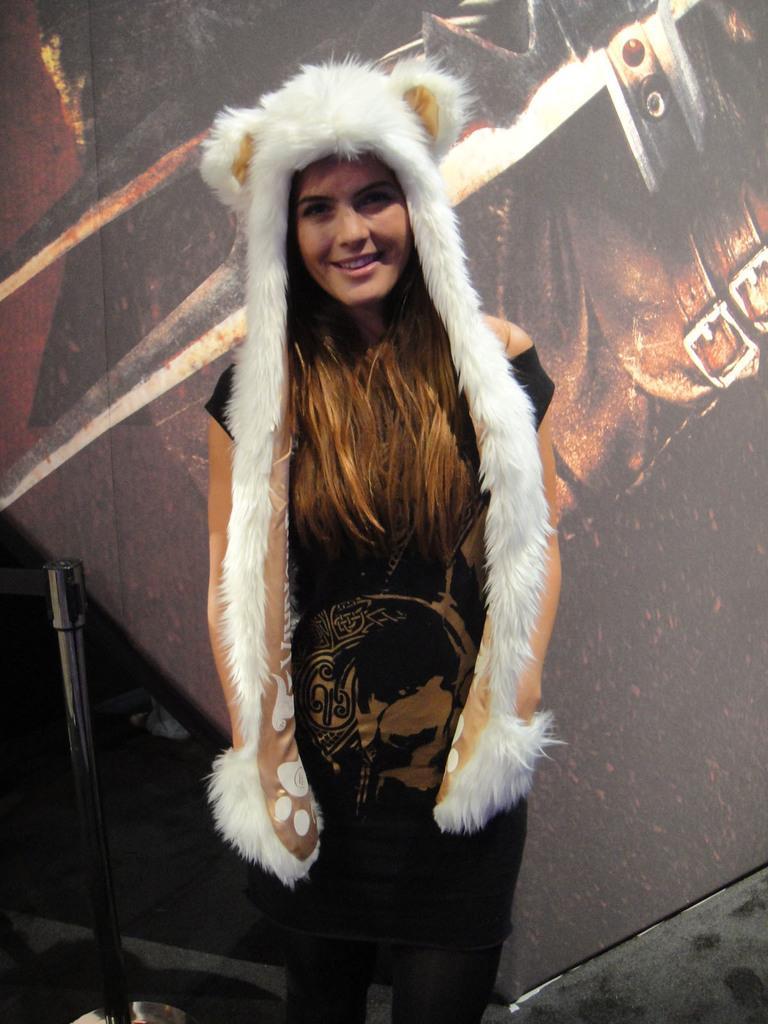In one or two sentences, can you explain what this image depicts? This image consists of a woman. She is wearing a black dress. She is smiling. 